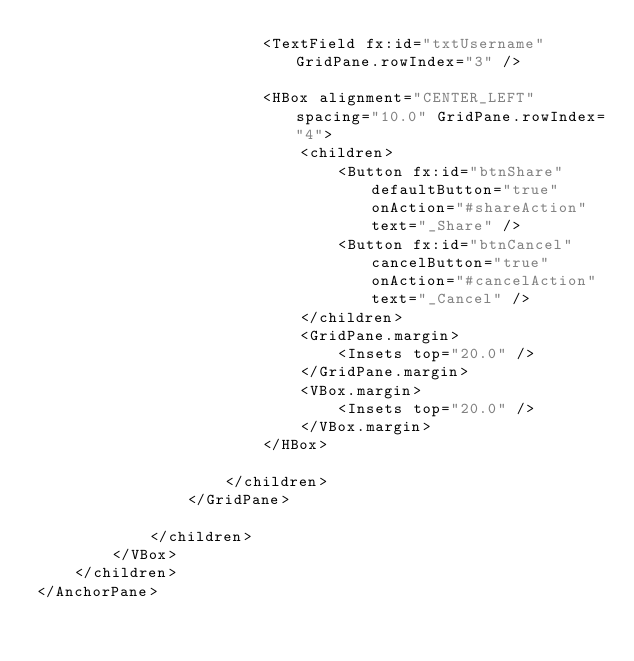Convert code to text. <code><loc_0><loc_0><loc_500><loc_500><_XML_>						<TextField fx:id="txtUsername" GridPane.rowIndex="3" />

						<HBox alignment="CENTER_LEFT" spacing="10.0" GridPane.rowIndex="4">
							<children>
								<Button fx:id="btnShare" defaultButton="true" onAction="#shareAction" text="_Share" />
								<Button fx:id="btnCancel" cancelButton="true" onAction="#cancelAction" text="_Cancel" />
							</children>
							<GridPane.margin>
								<Insets top="20.0" />
							</GridPane.margin>
							<VBox.margin>
								<Insets top="20.0" />
							</VBox.margin>
						</HBox>

					</children>
				</GridPane>

			</children>
		</VBox>
	</children>
</AnchorPane>
</code> 